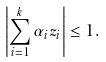Convert formula to latex. <formula><loc_0><loc_0><loc_500><loc_500>\left | \sum _ { i = 1 } ^ { k } \alpha _ { i } z _ { i } \right | \leq 1 .</formula> 